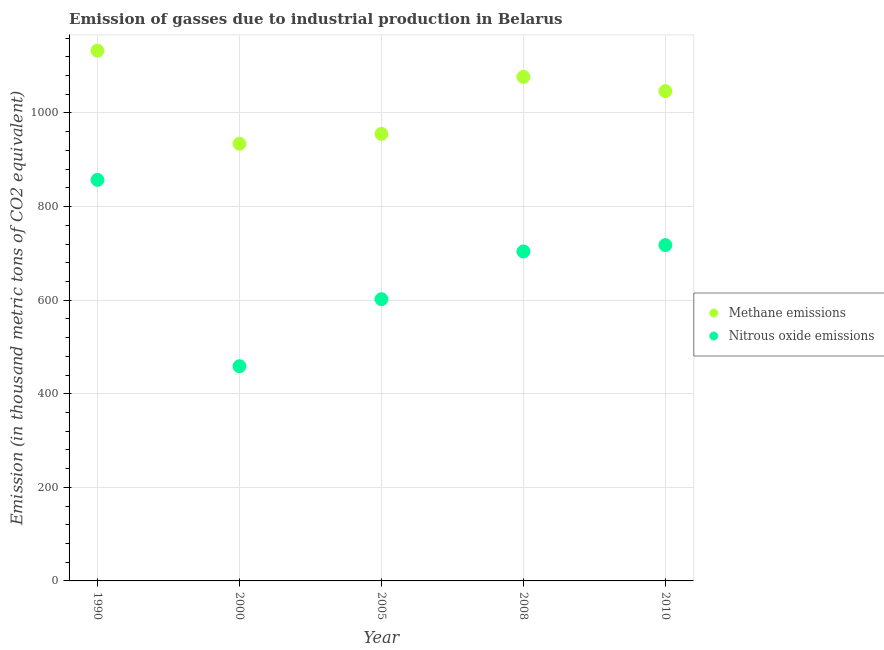Is the number of dotlines equal to the number of legend labels?
Your answer should be compact. Yes. What is the amount of methane emissions in 2005?
Provide a short and direct response. 955.3. Across all years, what is the maximum amount of nitrous oxide emissions?
Provide a succinct answer. 857. Across all years, what is the minimum amount of methane emissions?
Your response must be concise. 934.2. In which year was the amount of methane emissions maximum?
Provide a short and direct response. 1990. What is the total amount of methane emissions in the graph?
Your answer should be compact. 5146.6. What is the difference between the amount of methane emissions in 1990 and that in 2010?
Make the answer very short. 86.5. What is the difference between the amount of methane emissions in 2010 and the amount of nitrous oxide emissions in 2008?
Your answer should be compact. 342.6. What is the average amount of nitrous oxide emissions per year?
Keep it short and to the point. 667.94. In the year 1990, what is the difference between the amount of nitrous oxide emissions and amount of methane emissions?
Your answer should be compact. -276.2. In how many years, is the amount of nitrous oxide emissions greater than 680 thousand metric tons?
Offer a very short reply. 3. What is the ratio of the amount of methane emissions in 1990 to that in 2010?
Ensure brevity in your answer.  1.08. Is the difference between the amount of methane emissions in 1990 and 2000 greater than the difference between the amount of nitrous oxide emissions in 1990 and 2000?
Make the answer very short. No. What is the difference between the highest and the second highest amount of nitrous oxide emissions?
Your answer should be compact. 139.3. What is the difference between the highest and the lowest amount of nitrous oxide emissions?
Make the answer very short. 398.2. Is the sum of the amount of methane emissions in 2005 and 2010 greater than the maximum amount of nitrous oxide emissions across all years?
Your answer should be compact. Yes. Does the amount of nitrous oxide emissions monotonically increase over the years?
Offer a very short reply. No. Is the amount of nitrous oxide emissions strictly less than the amount of methane emissions over the years?
Your response must be concise. Yes. How many years are there in the graph?
Your answer should be very brief. 5. Does the graph contain any zero values?
Keep it short and to the point. No. Does the graph contain grids?
Your response must be concise. Yes. Where does the legend appear in the graph?
Give a very brief answer. Center right. How many legend labels are there?
Make the answer very short. 2. How are the legend labels stacked?
Provide a short and direct response. Vertical. What is the title of the graph?
Provide a short and direct response. Emission of gasses due to industrial production in Belarus. Does "Constant 2005 US$" appear as one of the legend labels in the graph?
Give a very brief answer. No. What is the label or title of the X-axis?
Offer a very short reply. Year. What is the label or title of the Y-axis?
Give a very brief answer. Emission (in thousand metric tons of CO2 equivalent). What is the Emission (in thousand metric tons of CO2 equivalent) of Methane emissions in 1990?
Ensure brevity in your answer.  1133.2. What is the Emission (in thousand metric tons of CO2 equivalent) in Nitrous oxide emissions in 1990?
Ensure brevity in your answer.  857. What is the Emission (in thousand metric tons of CO2 equivalent) of Methane emissions in 2000?
Offer a very short reply. 934.2. What is the Emission (in thousand metric tons of CO2 equivalent) of Nitrous oxide emissions in 2000?
Make the answer very short. 458.8. What is the Emission (in thousand metric tons of CO2 equivalent) in Methane emissions in 2005?
Keep it short and to the point. 955.3. What is the Emission (in thousand metric tons of CO2 equivalent) in Nitrous oxide emissions in 2005?
Provide a short and direct response. 602.1. What is the Emission (in thousand metric tons of CO2 equivalent) in Methane emissions in 2008?
Your answer should be compact. 1077.2. What is the Emission (in thousand metric tons of CO2 equivalent) in Nitrous oxide emissions in 2008?
Your answer should be very brief. 704.1. What is the Emission (in thousand metric tons of CO2 equivalent) of Methane emissions in 2010?
Keep it short and to the point. 1046.7. What is the Emission (in thousand metric tons of CO2 equivalent) of Nitrous oxide emissions in 2010?
Offer a terse response. 717.7. Across all years, what is the maximum Emission (in thousand metric tons of CO2 equivalent) of Methane emissions?
Offer a very short reply. 1133.2. Across all years, what is the maximum Emission (in thousand metric tons of CO2 equivalent) of Nitrous oxide emissions?
Your answer should be compact. 857. Across all years, what is the minimum Emission (in thousand metric tons of CO2 equivalent) of Methane emissions?
Provide a succinct answer. 934.2. Across all years, what is the minimum Emission (in thousand metric tons of CO2 equivalent) of Nitrous oxide emissions?
Provide a short and direct response. 458.8. What is the total Emission (in thousand metric tons of CO2 equivalent) in Methane emissions in the graph?
Ensure brevity in your answer.  5146.6. What is the total Emission (in thousand metric tons of CO2 equivalent) of Nitrous oxide emissions in the graph?
Provide a succinct answer. 3339.7. What is the difference between the Emission (in thousand metric tons of CO2 equivalent) in Methane emissions in 1990 and that in 2000?
Ensure brevity in your answer.  199. What is the difference between the Emission (in thousand metric tons of CO2 equivalent) of Nitrous oxide emissions in 1990 and that in 2000?
Your answer should be very brief. 398.2. What is the difference between the Emission (in thousand metric tons of CO2 equivalent) of Methane emissions in 1990 and that in 2005?
Provide a succinct answer. 177.9. What is the difference between the Emission (in thousand metric tons of CO2 equivalent) in Nitrous oxide emissions in 1990 and that in 2005?
Give a very brief answer. 254.9. What is the difference between the Emission (in thousand metric tons of CO2 equivalent) of Methane emissions in 1990 and that in 2008?
Your answer should be compact. 56. What is the difference between the Emission (in thousand metric tons of CO2 equivalent) of Nitrous oxide emissions in 1990 and that in 2008?
Make the answer very short. 152.9. What is the difference between the Emission (in thousand metric tons of CO2 equivalent) in Methane emissions in 1990 and that in 2010?
Keep it short and to the point. 86.5. What is the difference between the Emission (in thousand metric tons of CO2 equivalent) in Nitrous oxide emissions in 1990 and that in 2010?
Your response must be concise. 139.3. What is the difference between the Emission (in thousand metric tons of CO2 equivalent) of Methane emissions in 2000 and that in 2005?
Keep it short and to the point. -21.1. What is the difference between the Emission (in thousand metric tons of CO2 equivalent) of Nitrous oxide emissions in 2000 and that in 2005?
Offer a very short reply. -143.3. What is the difference between the Emission (in thousand metric tons of CO2 equivalent) in Methane emissions in 2000 and that in 2008?
Ensure brevity in your answer.  -143. What is the difference between the Emission (in thousand metric tons of CO2 equivalent) in Nitrous oxide emissions in 2000 and that in 2008?
Keep it short and to the point. -245.3. What is the difference between the Emission (in thousand metric tons of CO2 equivalent) of Methane emissions in 2000 and that in 2010?
Provide a short and direct response. -112.5. What is the difference between the Emission (in thousand metric tons of CO2 equivalent) of Nitrous oxide emissions in 2000 and that in 2010?
Your answer should be very brief. -258.9. What is the difference between the Emission (in thousand metric tons of CO2 equivalent) of Methane emissions in 2005 and that in 2008?
Offer a very short reply. -121.9. What is the difference between the Emission (in thousand metric tons of CO2 equivalent) of Nitrous oxide emissions in 2005 and that in 2008?
Ensure brevity in your answer.  -102. What is the difference between the Emission (in thousand metric tons of CO2 equivalent) in Methane emissions in 2005 and that in 2010?
Give a very brief answer. -91.4. What is the difference between the Emission (in thousand metric tons of CO2 equivalent) in Nitrous oxide emissions in 2005 and that in 2010?
Your answer should be compact. -115.6. What is the difference between the Emission (in thousand metric tons of CO2 equivalent) in Methane emissions in 2008 and that in 2010?
Offer a terse response. 30.5. What is the difference between the Emission (in thousand metric tons of CO2 equivalent) of Methane emissions in 1990 and the Emission (in thousand metric tons of CO2 equivalent) of Nitrous oxide emissions in 2000?
Offer a very short reply. 674.4. What is the difference between the Emission (in thousand metric tons of CO2 equivalent) in Methane emissions in 1990 and the Emission (in thousand metric tons of CO2 equivalent) in Nitrous oxide emissions in 2005?
Keep it short and to the point. 531.1. What is the difference between the Emission (in thousand metric tons of CO2 equivalent) of Methane emissions in 1990 and the Emission (in thousand metric tons of CO2 equivalent) of Nitrous oxide emissions in 2008?
Make the answer very short. 429.1. What is the difference between the Emission (in thousand metric tons of CO2 equivalent) in Methane emissions in 1990 and the Emission (in thousand metric tons of CO2 equivalent) in Nitrous oxide emissions in 2010?
Offer a terse response. 415.5. What is the difference between the Emission (in thousand metric tons of CO2 equivalent) of Methane emissions in 2000 and the Emission (in thousand metric tons of CO2 equivalent) of Nitrous oxide emissions in 2005?
Make the answer very short. 332.1. What is the difference between the Emission (in thousand metric tons of CO2 equivalent) of Methane emissions in 2000 and the Emission (in thousand metric tons of CO2 equivalent) of Nitrous oxide emissions in 2008?
Make the answer very short. 230.1. What is the difference between the Emission (in thousand metric tons of CO2 equivalent) of Methane emissions in 2000 and the Emission (in thousand metric tons of CO2 equivalent) of Nitrous oxide emissions in 2010?
Your answer should be very brief. 216.5. What is the difference between the Emission (in thousand metric tons of CO2 equivalent) in Methane emissions in 2005 and the Emission (in thousand metric tons of CO2 equivalent) in Nitrous oxide emissions in 2008?
Keep it short and to the point. 251.2. What is the difference between the Emission (in thousand metric tons of CO2 equivalent) in Methane emissions in 2005 and the Emission (in thousand metric tons of CO2 equivalent) in Nitrous oxide emissions in 2010?
Keep it short and to the point. 237.6. What is the difference between the Emission (in thousand metric tons of CO2 equivalent) of Methane emissions in 2008 and the Emission (in thousand metric tons of CO2 equivalent) of Nitrous oxide emissions in 2010?
Your answer should be very brief. 359.5. What is the average Emission (in thousand metric tons of CO2 equivalent) of Methane emissions per year?
Ensure brevity in your answer.  1029.32. What is the average Emission (in thousand metric tons of CO2 equivalent) in Nitrous oxide emissions per year?
Keep it short and to the point. 667.94. In the year 1990, what is the difference between the Emission (in thousand metric tons of CO2 equivalent) of Methane emissions and Emission (in thousand metric tons of CO2 equivalent) of Nitrous oxide emissions?
Make the answer very short. 276.2. In the year 2000, what is the difference between the Emission (in thousand metric tons of CO2 equivalent) in Methane emissions and Emission (in thousand metric tons of CO2 equivalent) in Nitrous oxide emissions?
Keep it short and to the point. 475.4. In the year 2005, what is the difference between the Emission (in thousand metric tons of CO2 equivalent) of Methane emissions and Emission (in thousand metric tons of CO2 equivalent) of Nitrous oxide emissions?
Your response must be concise. 353.2. In the year 2008, what is the difference between the Emission (in thousand metric tons of CO2 equivalent) in Methane emissions and Emission (in thousand metric tons of CO2 equivalent) in Nitrous oxide emissions?
Give a very brief answer. 373.1. In the year 2010, what is the difference between the Emission (in thousand metric tons of CO2 equivalent) of Methane emissions and Emission (in thousand metric tons of CO2 equivalent) of Nitrous oxide emissions?
Keep it short and to the point. 329. What is the ratio of the Emission (in thousand metric tons of CO2 equivalent) of Methane emissions in 1990 to that in 2000?
Your answer should be very brief. 1.21. What is the ratio of the Emission (in thousand metric tons of CO2 equivalent) of Nitrous oxide emissions in 1990 to that in 2000?
Keep it short and to the point. 1.87. What is the ratio of the Emission (in thousand metric tons of CO2 equivalent) in Methane emissions in 1990 to that in 2005?
Make the answer very short. 1.19. What is the ratio of the Emission (in thousand metric tons of CO2 equivalent) of Nitrous oxide emissions in 1990 to that in 2005?
Offer a terse response. 1.42. What is the ratio of the Emission (in thousand metric tons of CO2 equivalent) of Methane emissions in 1990 to that in 2008?
Your response must be concise. 1.05. What is the ratio of the Emission (in thousand metric tons of CO2 equivalent) in Nitrous oxide emissions in 1990 to that in 2008?
Give a very brief answer. 1.22. What is the ratio of the Emission (in thousand metric tons of CO2 equivalent) of Methane emissions in 1990 to that in 2010?
Keep it short and to the point. 1.08. What is the ratio of the Emission (in thousand metric tons of CO2 equivalent) in Nitrous oxide emissions in 1990 to that in 2010?
Provide a succinct answer. 1.19. What is the ratio of the Emission (in thousand metric tons of CO2 equivalent) in Methane emissions in 2000 to that in 2005?
Your answer should be compact. 0.98. What is the ratio of the Emission (in thousand metric tons of CO2 equivalent) in Nitrous oxide emissions in 2000 to that in 2005?
Your answer should be very brief. 0.76. What is the ratio of the Emission (in thousand metric tons of CO2 equivalent) in Methane emissions in 2000 to that in 2008?
Make the answer very short. 0.87. What is the ratio of the Emission (in thousand metric tons of CO2 equivalent) of Nitrous oxide emissions in 2000 to that in 2008?
Keep it short and to the point. 0.65. What is the ratio of the Emission (in thousand metric tons of CO2 equivalent) in Methane emissions in 2000 to that in 2010?
Provide a short and direct response. 0.89. What is the ratio of the Emission (in thousand metric tons of CO2 equivalent) of Nitrous oxide emissions in 2000 to that in 2010?
Keep it short and to the point. 0.64. What is the ratio of the Emission (in thousand metric tons of CO2 equivalent) in Methane emissions in 2005 to that in 2008?
Keep it short and to the point. 0.89. What is the ratio of the Emission (in thousand metric tons of CO2 equivalent) of Nitrous oxide emissions in 2005 to that in 2008?
Provide a short and direct response. 0.86. What is the ratio of the Emission (in thousand metric tons of CO2 equivalent) in Methane emissions in 2005 to that in 2010?
Keep it short and to the point. 0.91. What is the ratio of the Emission (in thousand metric tons of CO2 equivalent) in Nitrous oxide emissions in 2005 to that in 2010?
Make the answer very short. 0.84. What is the ratio of the Emission (in thousand metric tons of CO2 equivalent) in Methane emissions in 2008 to that in 2010?
Provide a succinct answer. 1.03. What is the ratio of the Emission (in thousand metric tons of CO2 equivalent) of Nitrous oxide emissions in 2008 to that in 2010?
Make the answer very short. 0.98. What is the difference between the highest and the second highest Emission (in thousand metric tons of CO2 equivalent) in Nitrous oxide emissions?
Offer a very short reply. 139.3. What is the difference between the highest and the lowest Emission (in thousand metric tons of CO2 equivalent) of Methane emissions?
Provide a succinct answer. 199. What is the difference between the highest and the lowest Emission (in thousand metric tons of CO2 equivalent) in Nitrous oxide emissions?
Offer a very short reply. 398.2. 